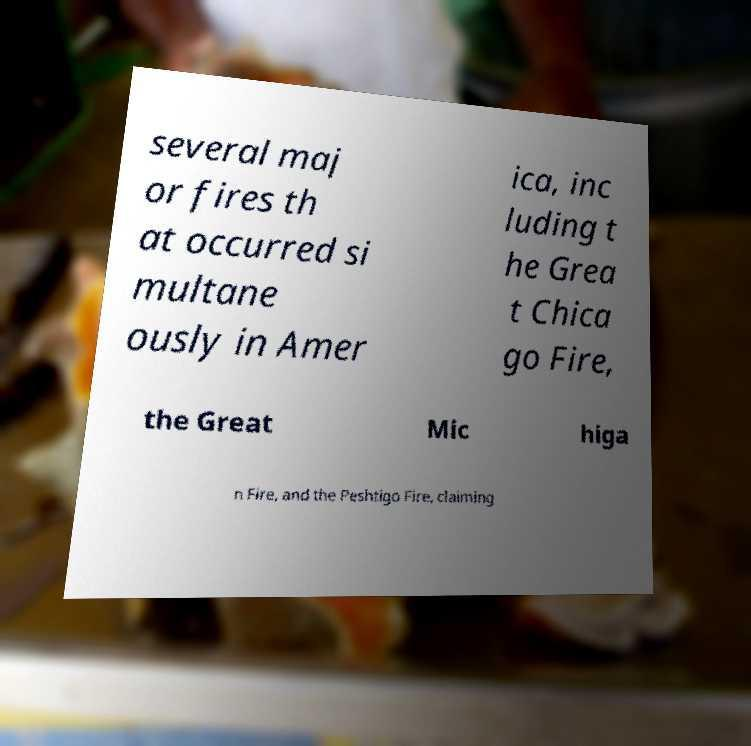Please identify and transcribe the text found in this image. several maj or fires th at occurred si multane ously in Amer ica, inc luding t he Grea t Chica go Fire, the Great Mic higa n Fire, and the Peshtigo Fire, claiming 